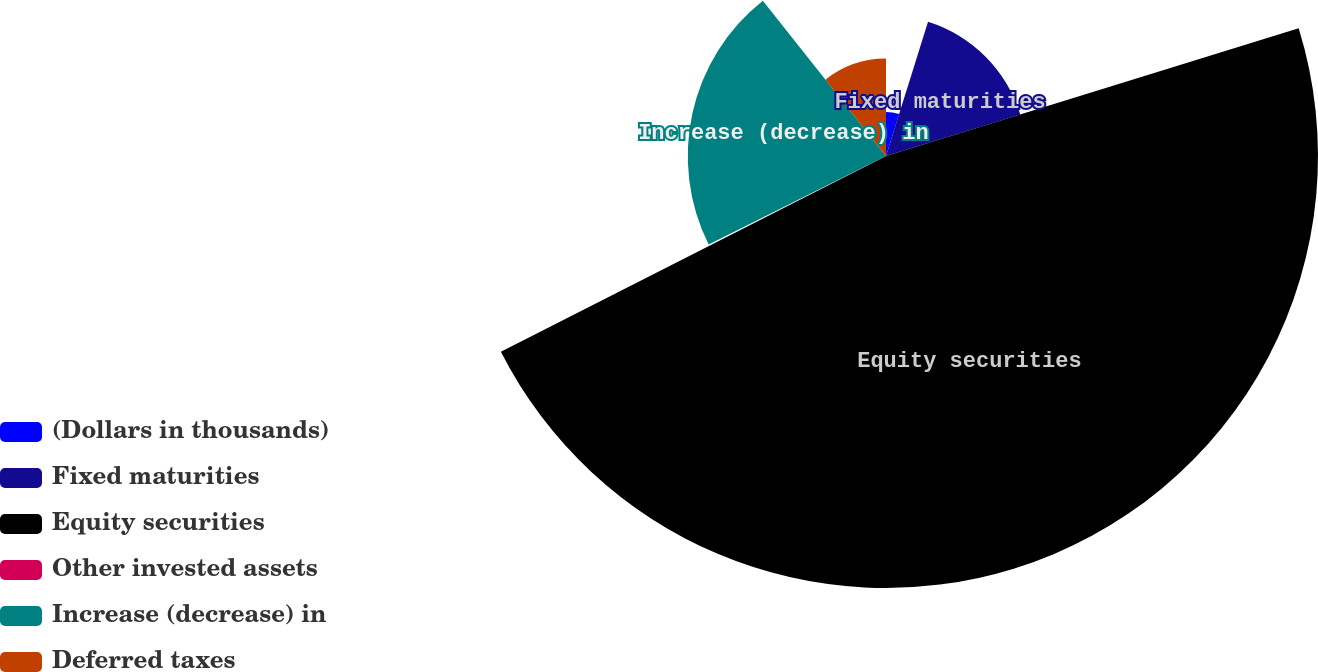Convert chart. <chart><loc_0><loc_0><loc_500><loc_500><pie_chart><fcel>(Dollars in thousands)<fcel>Fixed maturities<fcel>Equity securities<fcel>Other invested assets<fcel>Increase (decrease) in<fcel>Deferred taxes<nl><fcel>4.83%<fcel>15.39%<fcel>47.29%<fcel>0.11%<fcel>21.7%<fcel>10.67%<nl></chart> 